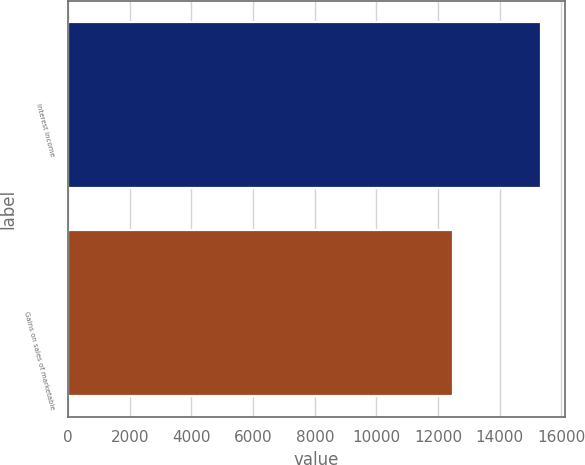Convert chart. <chart><loc_0><loc_0><loc_500><loc_500><bar_chart><fcel>Interest income<fcel>Gains on sales of marketable<nl><fcel>15350<fcel>12491<nl></chart> 